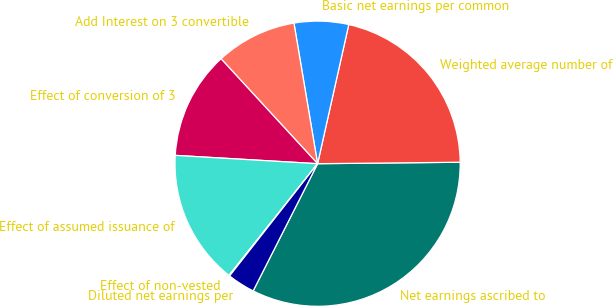Convert chart to OTSL. <chart><loc_0><loc_0><loc_500><loc_500><pie_chart><fcel>Net earnings ascribed to<fcel>Weighted average number of<fcel>Basic net earnings per common<fcel>Add Interest on 3 convertible<fcel>Effect of conversion of 3<fcel>Effect of assumed issuance of<fcel>Effect of non-vested<fcel>Diluted net earnings per<nl><fcel>32.63%<fcel>21.33%<fcel>6.16%<fcel>9.19%<fcel>12.23%<fcel>15.26%<fcel>0.09%<fcel>3.12%<nl></chart> 